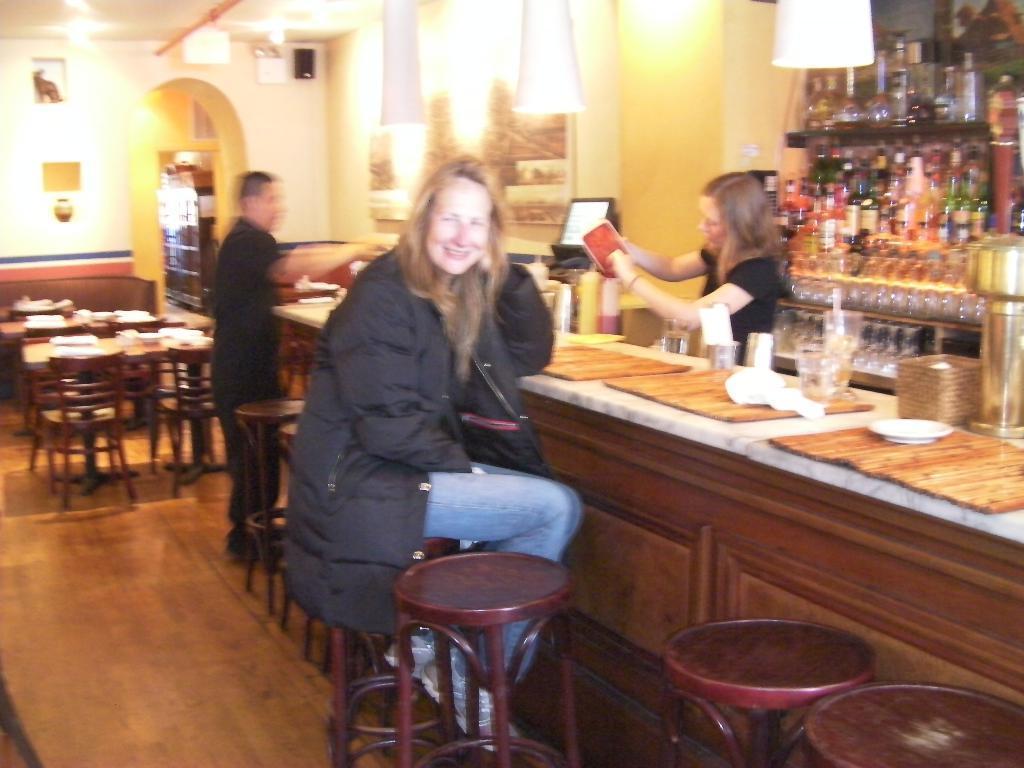Describe this image in one or two sentences. Here we can see a woman sitting on the chair. She is smiling. This is table. On the table there glasses, plates, and a bottle. There are chairs. This is floor. Here we can see two persons are standing on the floor. There is a screen. In the background there is a wall and these are the lights. Here we can see a rack and there are bottles. 